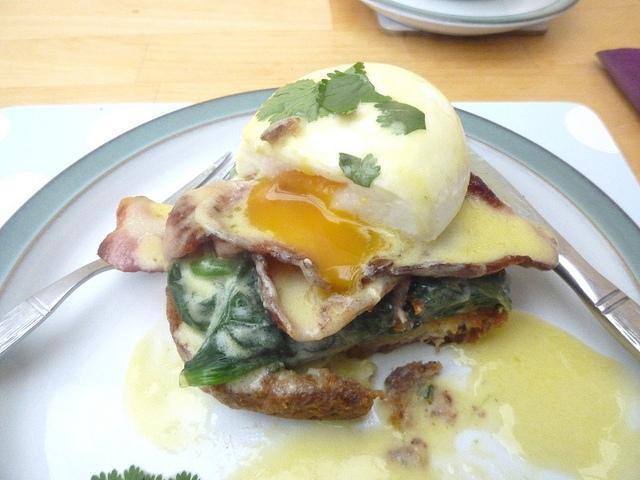What is near the top of the food pile?
Choose the right answer from the provided options to respond to the question.
Options: Egg, cabbage, hot dog, apple. Egg. 